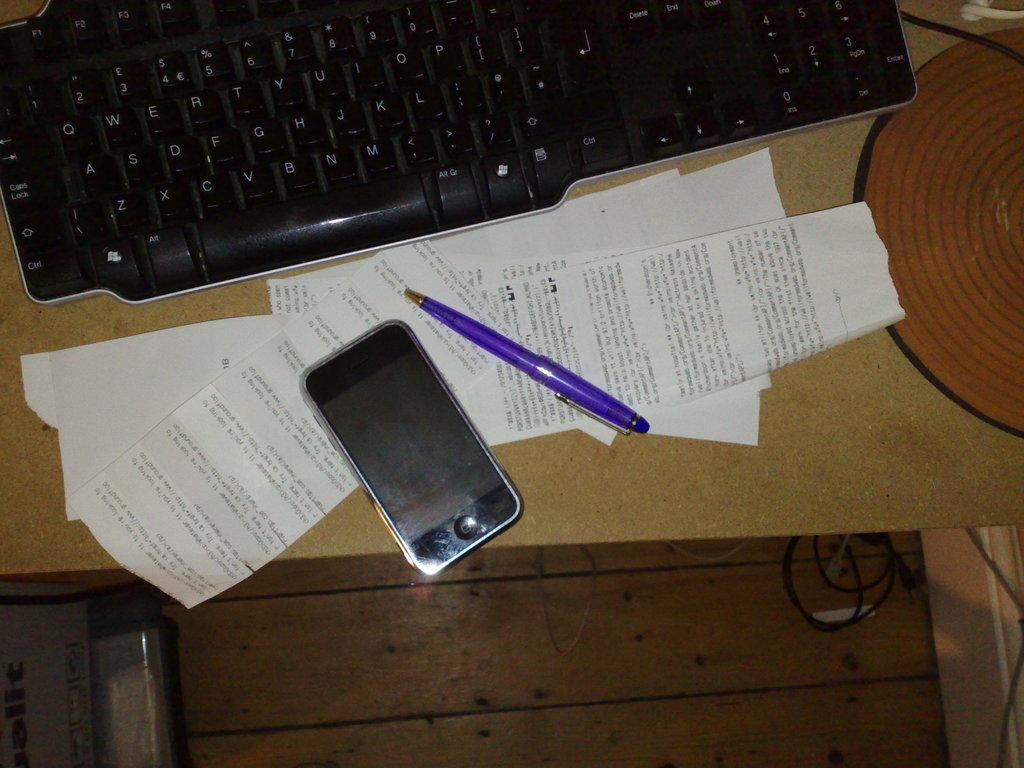What is on the table in the image? There is a keyboard, a pen, papers, and a mobile phone on the table. What might be used for typing in the image? The keyboard on the table can be used for typing. What can be used for writing in the image? The pen on the table can be used for writing. What might be used for reading or writing on in the image? The papers on the table can be used for reading or writing on. What might be used for communication in the image? The mobile phone on the table can be used for communication. How many books are stacked on the table in the image? There are no books visible in the image; only a keyboard, pen, papers, and a mobile phone are present on the table. What type of brake is used to stop the pen from rolling off the table? There is no brake present in the image, and the pen is not rolling off the table. 